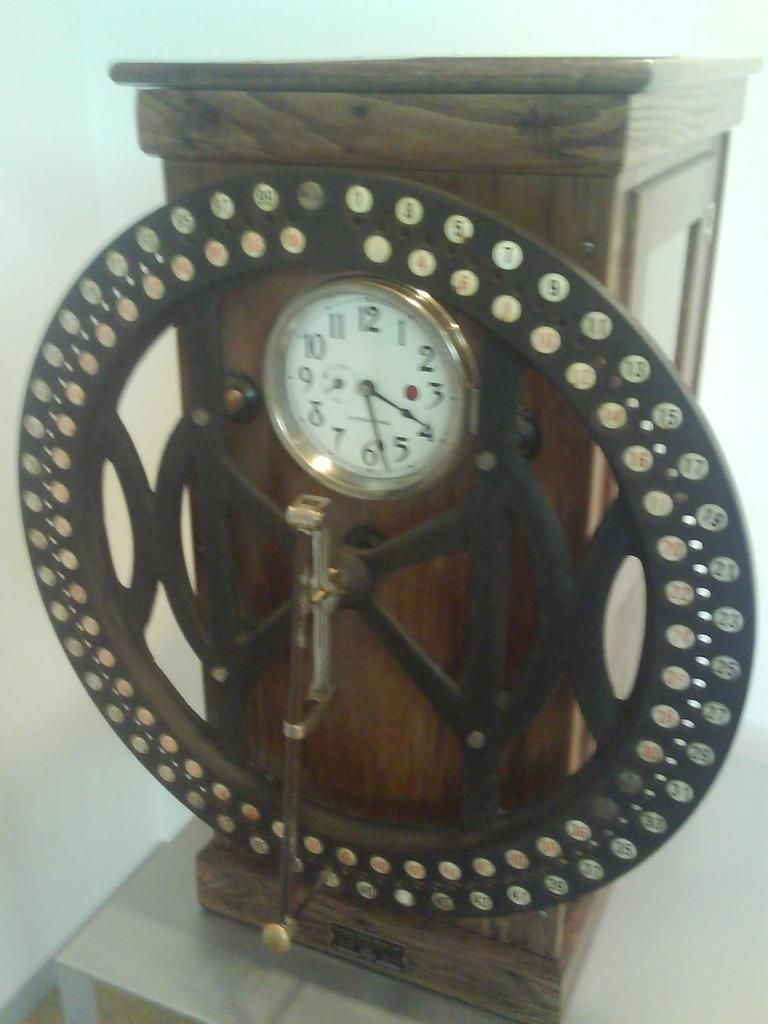<image>
Create a compact narrative representing the image presented. A clock that reads 4:27 is mounted on a piece of wood. 